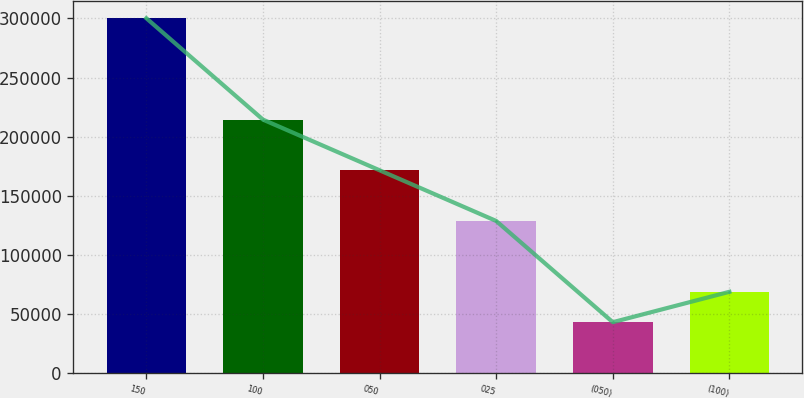Convert chart to OTSL. <chart><loc_0><loc_0><loc_500><loc_500><bar_chart><fcel>150<fcel>100<fcel>050<fcel>025<fcel>(050)<fcel>(100)<nl><fcel>300200<fcel>214400<fcel>171500<fcel>128600<fcel>42900<fcel>68630<nl></chart> 